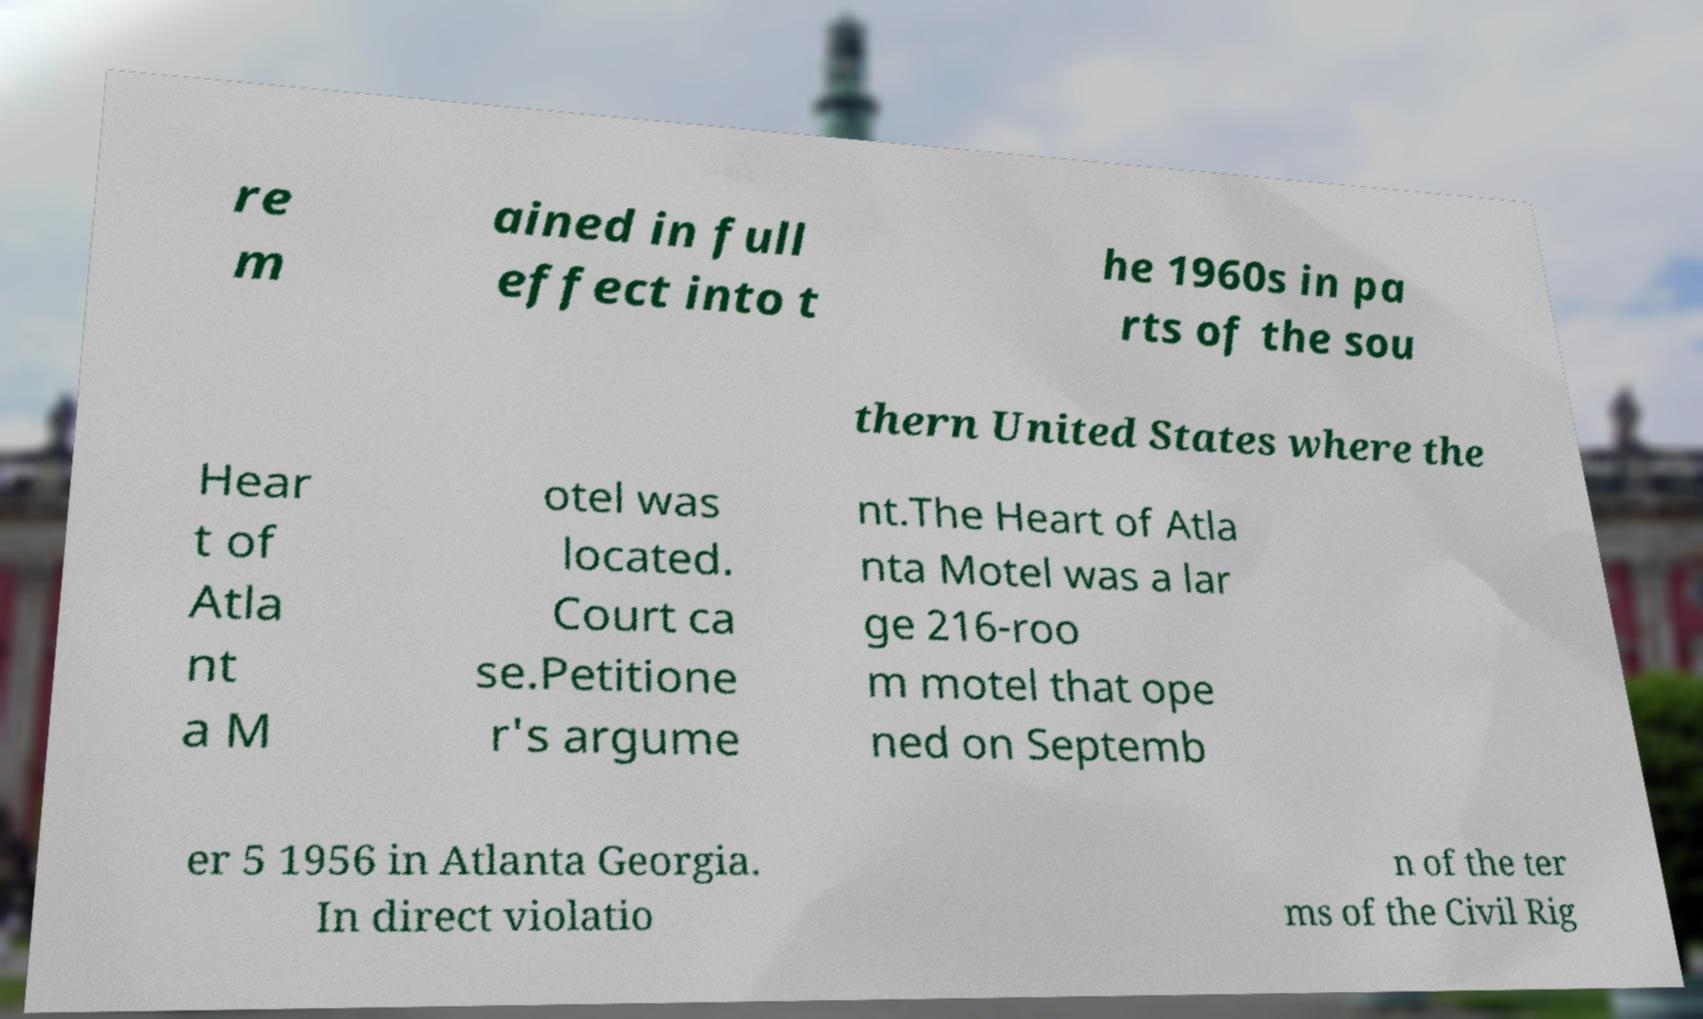There's text embedded in this image that I need extracted. Can you transcribe it verbatim? re m ained in full effect into t he 1960s in pa rts of the sou thern United States where the Hear t of Atla nt a M otel was located. Court ca se.Petitione r's argume nt.The Heart of Atla nta Motel was a lar ge 216-roo m motel that ope ned on Septemb er 5 1956 in Atlanta Georgia. In direct violatio n of the ter ms of the Civil Rig 